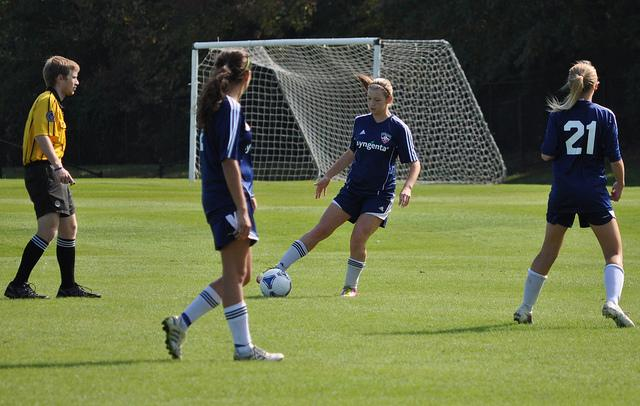Who will try to get the ball from the person who touches it? Please explain your reasoning. yellow person. The referee can call out the person who touches the ball. 